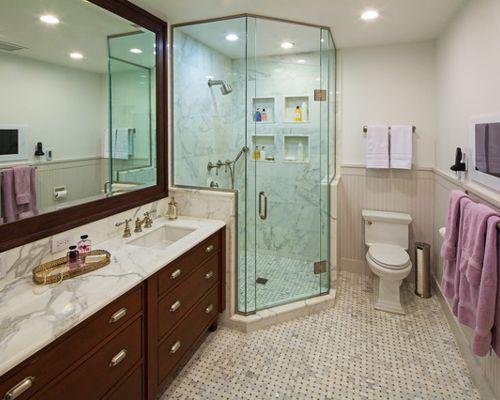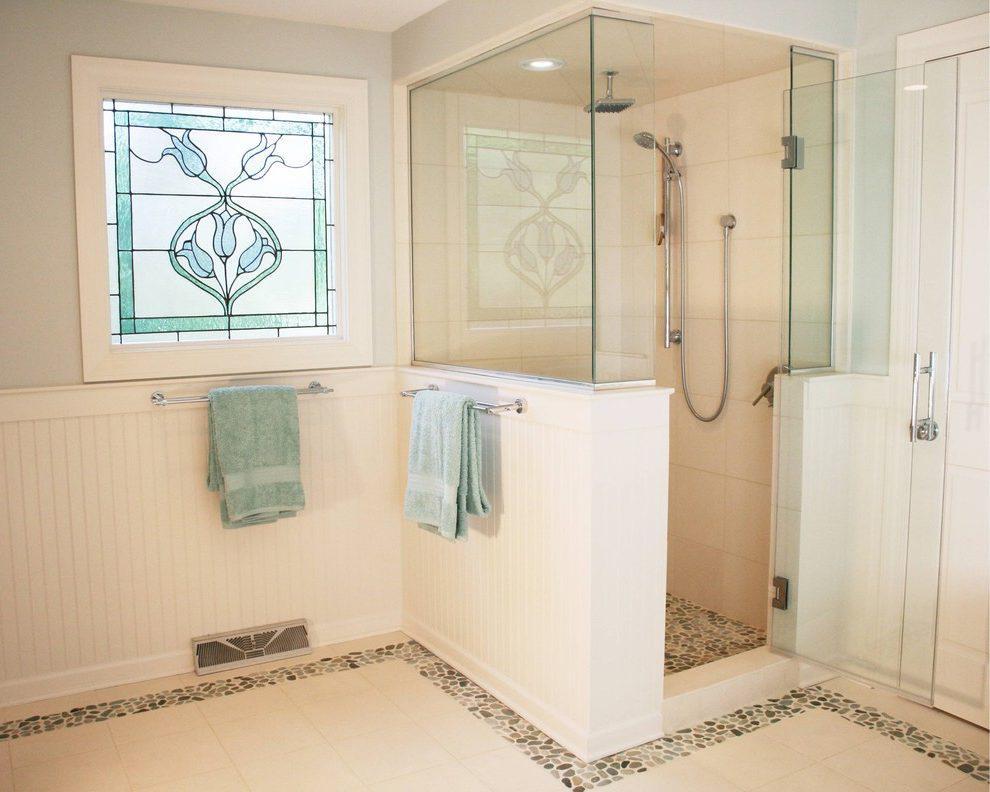The first image is the image on the left, the second image is the image on the right. Evaluate the accuracy of this statement regarding the images: "There are two sinks.". Is it true? Answer yes or no. No. The first image is the image on the left, the second image is the image on the right. Given the left and right images, does the statement "There is a toilet in one image and a shower in the other." hold true? Answer yes or no. Yes. 